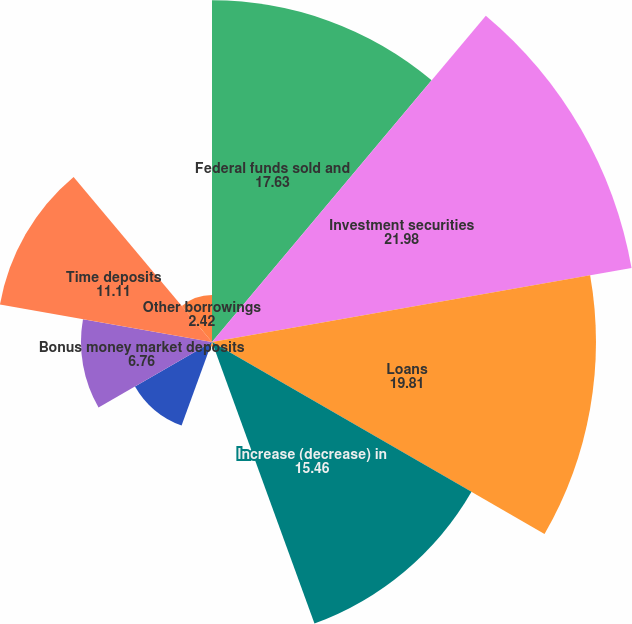<chart> <loc_0><loc_0><loc_500><loc_500><pie_chart><fcel>Federal funds sold and<fcel>Investment securities<fcel>Loans<fcel>Increase (decrease) in<fcel>NOW deposits<fcel>Regular money market deposits<fcel>Bonus money market deposits<fcel>Time deposits<fcel>Other borrowings<nl><fcel>17.63%<fcel>21.98%<fcel>19.81%<fcel>15.46%<fcel>0.24%<fcel>4.59%<fcel>6.76%<fcel>11.11%<fcel>2.42%<nl></chart> 